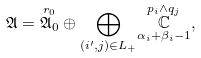Convert formula to latex. <formula><loc_0><loc_0><loc_500><loc_500>\mathfrak { A } = \overset { r _ { 0 } } { \mathfrak { A } _ { 0 } } \oplus \underset { ( i ^ { \prime } , j ) \in L _ { + } } { \bigoplus } \underset { \alpha _ { i } + \beta _ { i } - 1 } { \overset { p _ { i } \wedge q _ { j } } { \mathbb { C } } } ,</formula> 